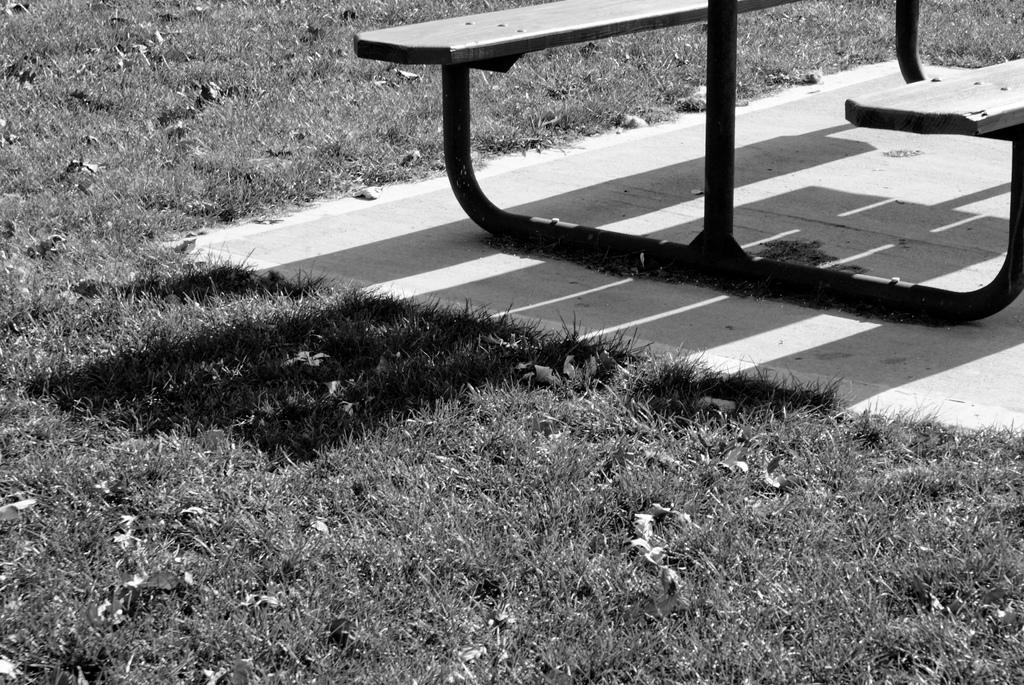What type of vegetation is present in the image? There is grass in the image. What type of seating is visible in the image? There is a bench in the image. What can be seen in the image that indicates the presence of light? There is a shadow in the image. How many colors are present in the image? The image is black and white in color. What type of straw is being used by the person sitting on the bench in the image? There is no person or straw present in the image; it only features grass, a bench, a shadow, and is black and white in color. What type of seed can be seen growing on the bench in the image? There are no seeds or plants growing on the bench in the image; it is a bench without any vegetation. 